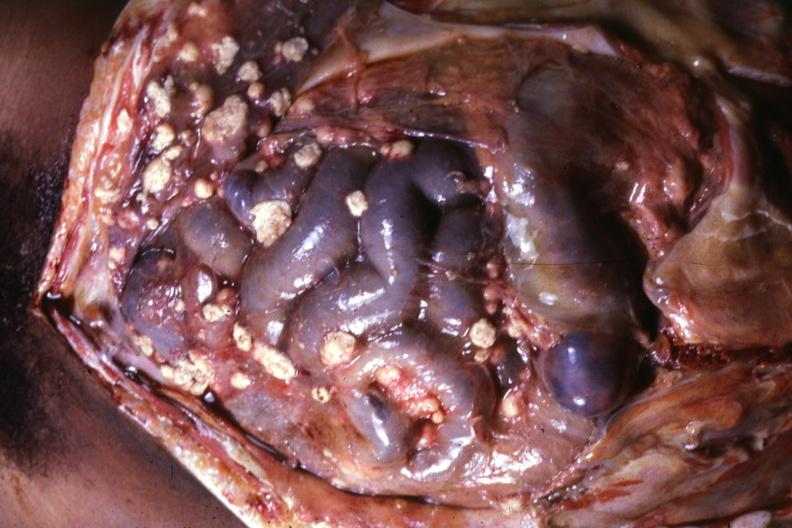what is present?
Answer the question using a single word or phrase. Peritoneum 